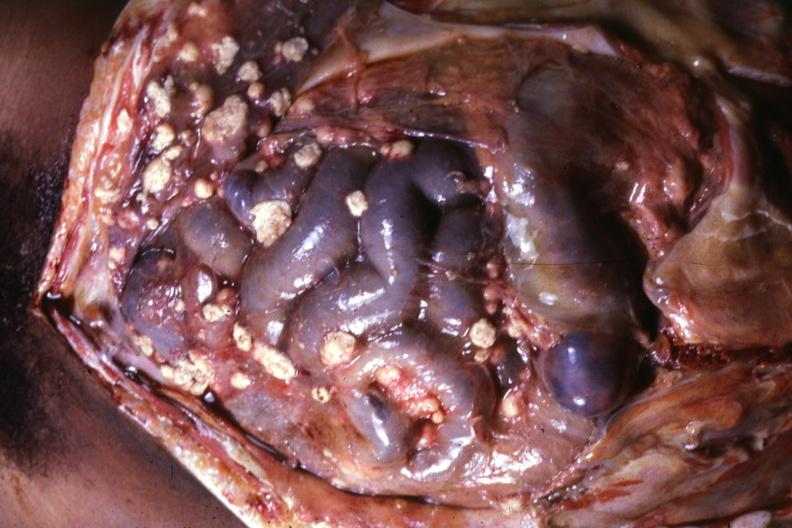what is present?
Answer the question using a single word or phrase. Peritoneum 